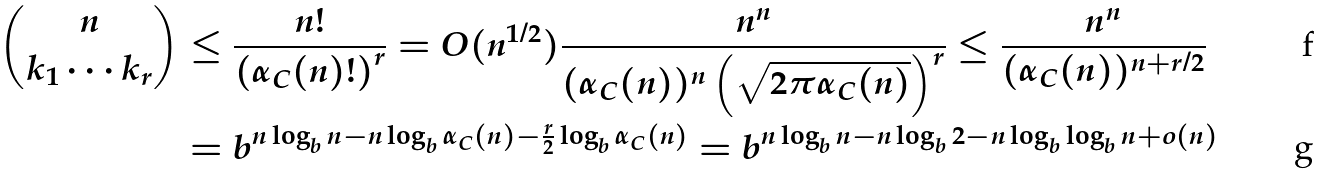Convert formula to latex. <formula><loc_0><loc_0><loc_500><loc_500>\binom { n } { k _ { 1 } \cdots k _ { r } } & \leq \frac { n ! } { \left ( \alpha _ { C } ( n ) ! \right ) ^ { r } } = O ( n ^ { 1 / 2 } ) \frac { n ^ { n } } { ( \alpha _ { C } ( n ) ) ^ { n } \left ( \sqrt { 2 \pi \alpha _ { C } ( n ) } \right ) ^ { r } } \leq \frac { n ^ { n } } { ( \alpha _ { C } ( n ) ) ^ { n + r / 2 } } \\ & = b ^ { n \log _ { b } n - n \log _ { b } \alpha _ { C } ( n ) - \frac { r } { 2 } \log _ { b } \alpha _ { C } ( n ) } = b ^ { n \log _ { b } n - n \log _ { b } 2 - n \log _ { b } \log _ { b } n + o ( n ) }</formula> 